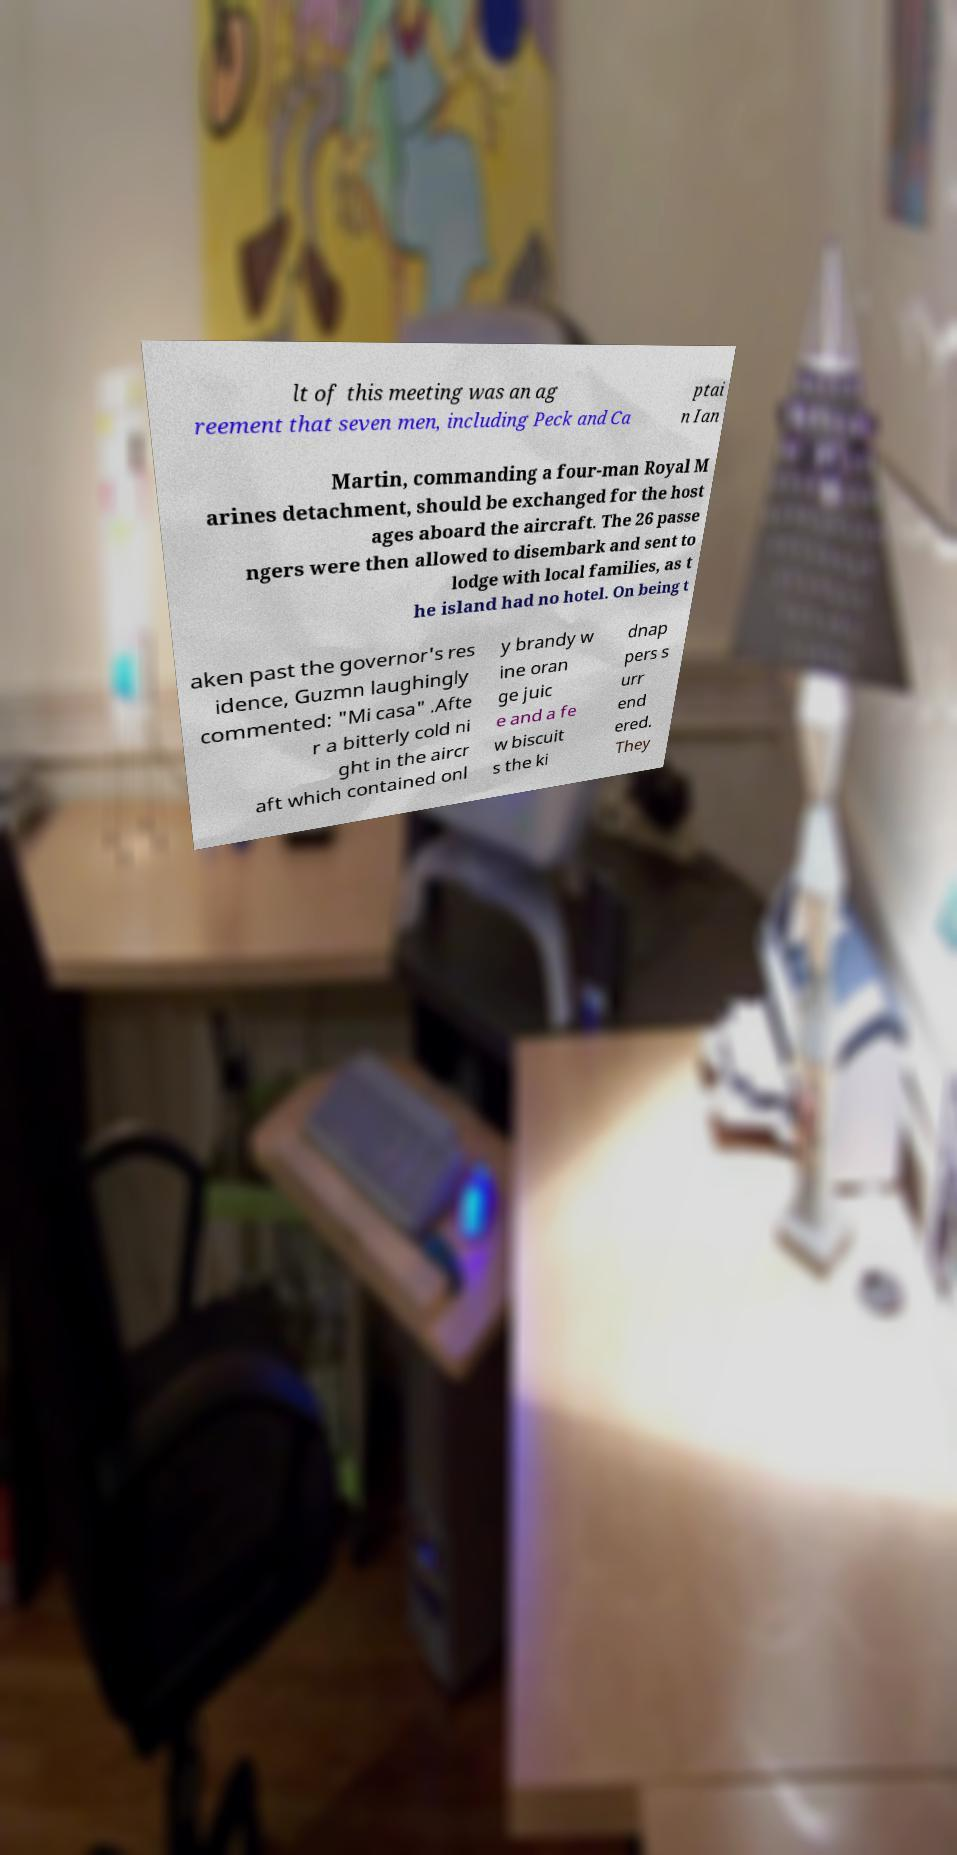For documentation purposes, I need the text within this image transcribed. Could you provide that? lt of this meeting was an ag reement that seven men, including Peck and Ca ptai n Ian Martin, commanding a four-man Royal M arines detachment, should be exchanged for the host ages aboard the aircraft. The 26 passe ngers were then allowed to disembark and sent to lodge with local families, as t he island had no hotel. On being t aken past the governor's res idence, Guzmn laughingly commented: "Mi casa" .Afte r a bitterly cold ni ght in the aircr aft which contained onl y brandy w ine oran ge juic e and a fe w biscuit s the ki dnap pers s urr end ered. They 